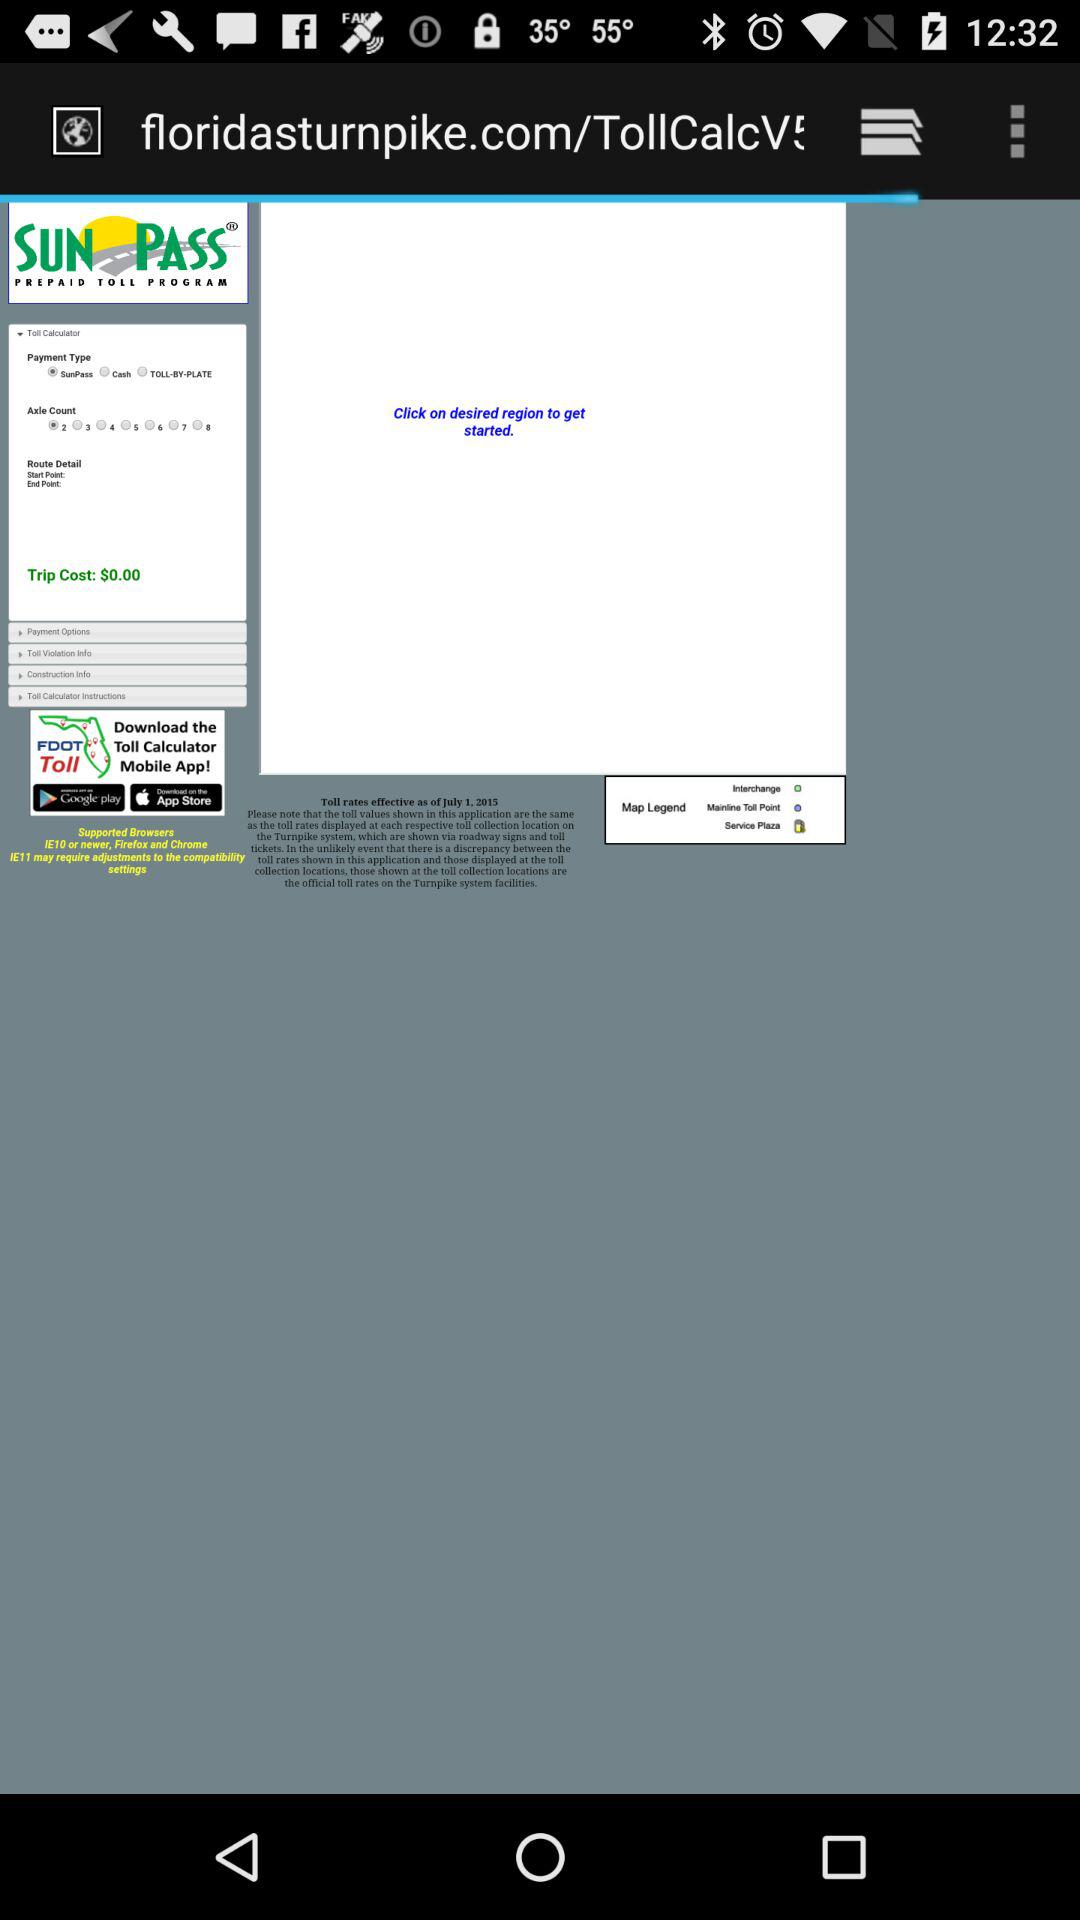What is the selected axle count? The selected axle count is 2. 